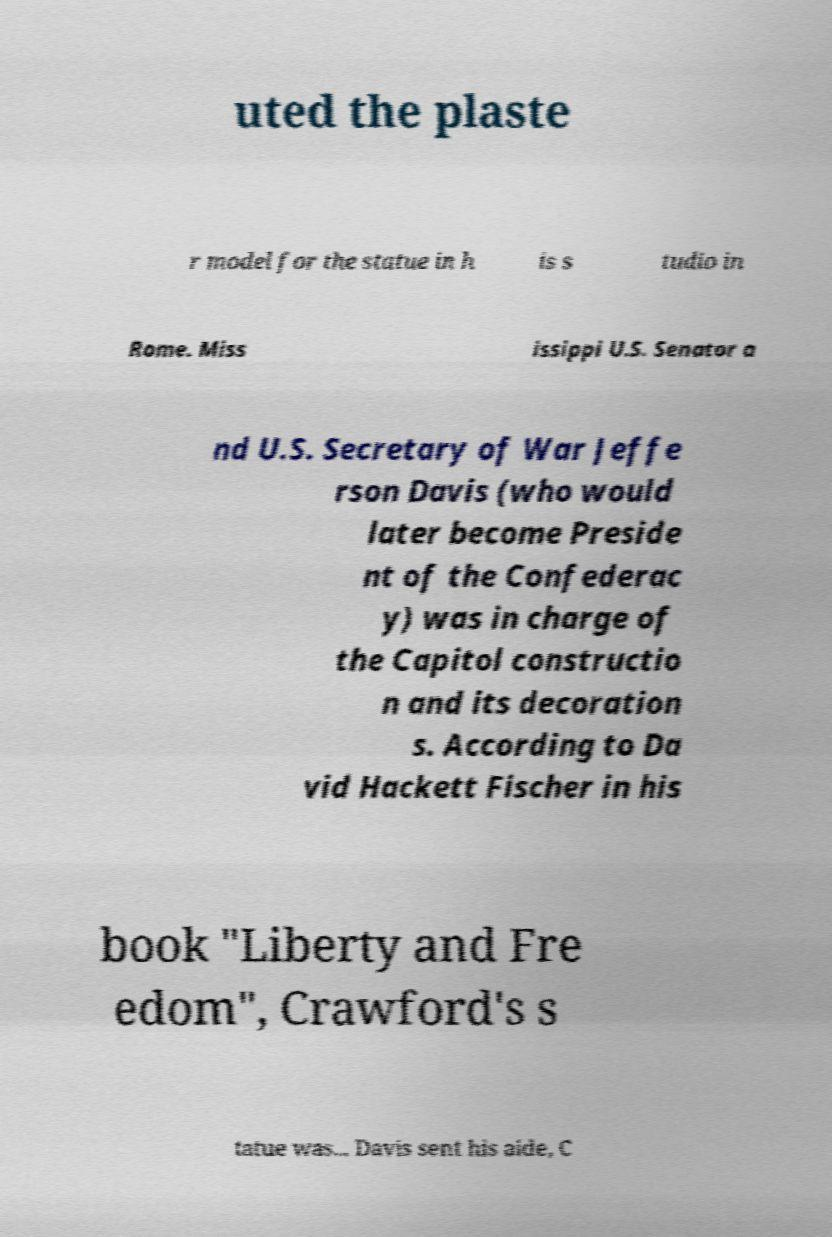There's text embedded in this image that I need extracted. Can you transcribe it verbatim? uted the plaste r model for the statue in h is s tudio in Rome. Miss issippi U.S. Senator a nd U.S. Secretary of War Jeffe rson Davis (who would later become Preside nt of the Confederac y) was in charge of the Capitol constructio n and its decoration s. According to Da vid Hackett Fischer in his book "Liberty and Fre edom", Crawford's s tatue was... Davis sent his aide, C 